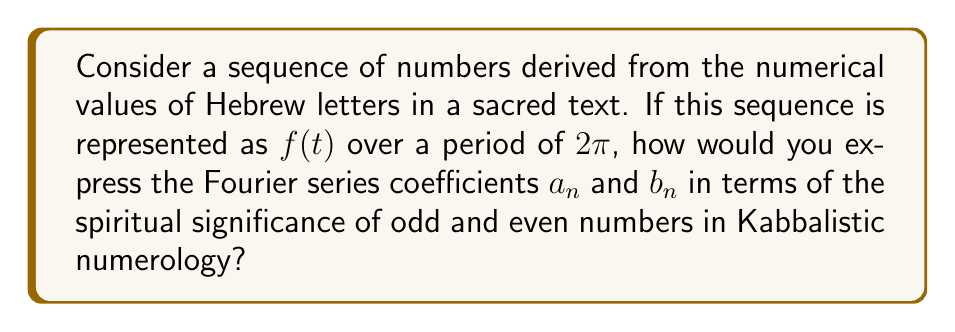Could you help me with this problem? To approach this problem, we need to consider both the mathematical aspects of Fourier series and the numerological concepts in Kabbalah:

1. In Fourier series, a periodic function $f(t)$ can be expressed as:

   $$f(t) = \frac{a_0}{2} + \sum_{n=1}^{\infty} (a_n \cos(nt) + b_n \sin(nt))$$

   where the coefficients are given by:

   $$a_n = \frac{1}{\pi} \int_{-\pi}^{\pi} f(t) \cos(nt) dt$$
   $$b_n = \frac{1}{\pi} \int_{-\pi}^{\pi} f(t) \sin(nt) dt$$

2. In Kabbalistic numerology, odd numbers are often associated with the divine or spiritual realm, while even numbers are associated with the material world.

3. To incorporate this numerological concept, we can modify the Fourier coefficients as follows:

   For odd $n$:
   $$a_n = \frac{\alpha}{\pi} \int_{-\pi}^{\pi} f(t) \cos(nt) dt$$
   $$b_n = \frac{\alpha}{\pi} \int_{-\pi}^{\pi} f(t) \sin(nt) dt$$

   For even $n$:
   $$a_n = \frac{\beta}{\pi} \int_{-\pi}^{\pi} f(t) \cos(nt) dt$$
   $$b_n = \frac{\beta}{\pi} \int_{-\pi}^{\pi} f(t) \sin(nt) dt$$

   where $\alpha$ represents the spiritual significance factor for odd numbers and $\beta$ represents the material significance factor for even numbers in Kabbalistic numerology.

4. The ratio $\frac{\alpha}{\beta}$ could be set to a value that reflects the relative importance of spiritual versus material aspects in the particular sacred text being analyzed.

5. This approach allows for a mathematical representation of the sequence that incorporates both the frequency domain analysis of Fourier series and the numerological significance in Kabbalah.
Answer: The Fourier series coefficients incorporating Kabbalistic numerology are:

For odd $n$:
$$a_n = \frac{\alpha}{\pi} \int_{-\pi}^{\pi} f(t) \cos(nt) dt$$
$$b_n = \frac{\alpha}{\pi} \int_{-\pi}^{\pi} f(t) \sin(nt) dt$$

For even $n$:
$$a_n = \frac{\beta}{\pi} \int_{-\pi}^{\pi} f(t) \cos(nt) dt$$
$$b_n = \frac{\beta}{\pi} \int_{-\pi}^{\pi} f(t) \sin(nt) dt$$

where $\alpha$ and $\beta$ represent the spiritual and material significance factors, respectively. 